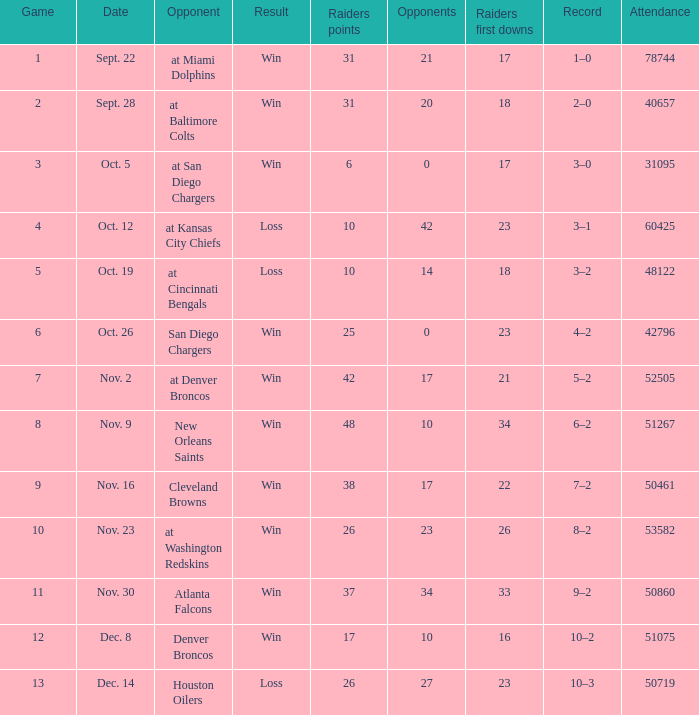In the game with an attendance of 60,425 individuals, who was the opposing team? At kansas city chiefs. 